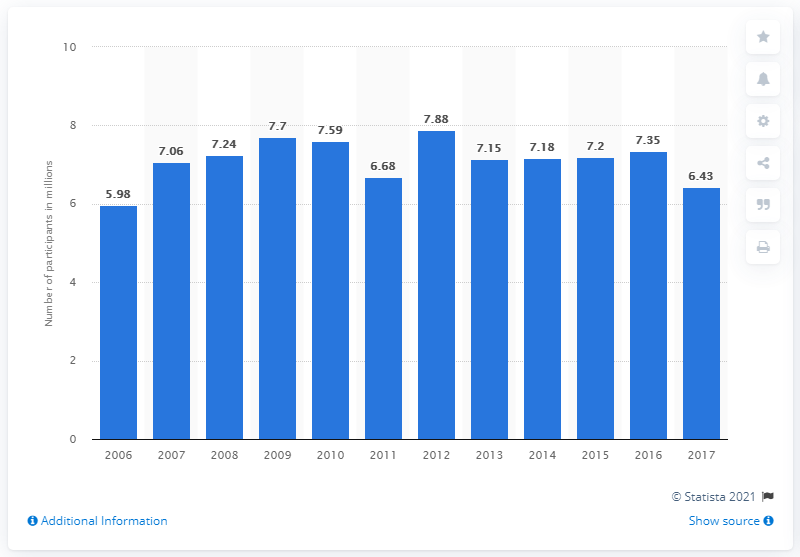Highlight a few significant elements in this photo. In 2017, the total number of participants in badminton was 6,430. 